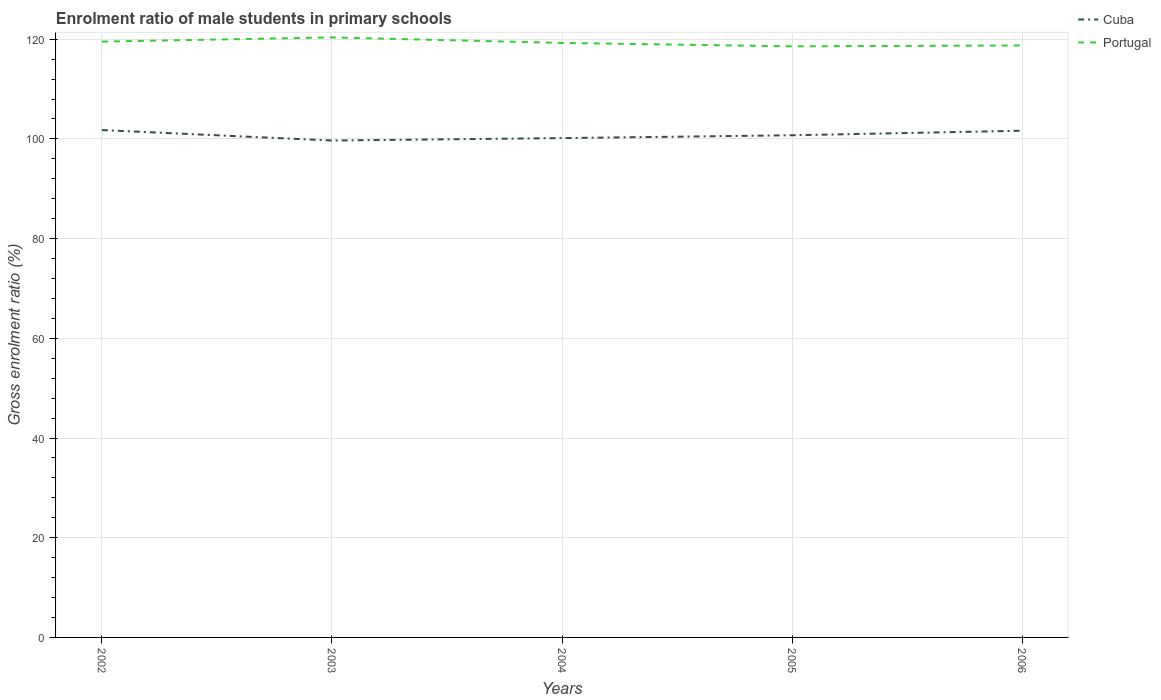Is the number of lines equal to the number of legend labels?
Make the answer very short. Yes. Across all years, what is the maximum enrolment ratio of male students in primary schools in Cuba?
Offer a very short reply. 99.68. What is the total enrolment ratio of male students in primary schools in Cuba in the graph?
Give a very brief answer. -0.57. What is the difference between the highest and the second highest enrolment ratio of male students in primary schools in Cuba?
Offer a terse response. 2.1. Is the enrolment ratio of male students in primary schools in Cuba strictly greater than the enrolment ratio of male students in primary schools in Portugal over the years?
Your answer should be very brief. Yes. How many years are there in the graph?
Provide a short and direct response. 5. What is the difference between two consecutive major ticks on the Y-axis?
Provide a short and direct response. 20. Are the values on the major ticks of Y-axis written in scientific E-notation?
Keep it short and to the point. No. Where does the legend appear in the graph?
Offer a terse response. Top right. How many legend labels are there?
Make the answer very short. 2. What is the title of the graph?
Provide a succinct answer. Enrolment ratio of male students in primary schools. What is the label or title of the X-axis?
Ensure brevity in your answer.  Years. What is the label or title of the Y-axis?
Offer a very short reply. Gross enrolment ratio (%). What is the Gross enrolment ratio (%) in Cuba in 2002?
Your response must be concise. 101.78. What is the Gross enrolment ratio (%) of Portugal in 2002?
Provide a short and direct response. 119.52. What is the Gross enrolment ratio (%) of Cuba in 2003?
Your response must be concise. 99.68. What is the Gross enrolment ratio (%) in Portugal in 2003?
Keep it short and to the point. 120.37. What is the Gross enrolment ratio (%) of Cuba in 2004?
Provide a succinct answer. 100.17. What is the Gross enrolment ratio (%) of Portugal in 2004?
Ensure brevity in your answer.  119.26. What is the Gross enrolment ratio (%) in Cuba in 2005?
Ensure brevity in your answer.  100.73. What is the Gross enrolment ratio (%) of Portugal in 2005?
Your answer should be compact. 118.57. What is the Gross enrolment ratio (%) of Cuba in 2006?
Your answer should be very brief. 101.65. What is the Gross enrolment ratio (%) in Portugal in 2006?
Make the answer very short. 118.76. Across all years, what is the maximum Gross enrolment ratio (%) in Cuba?
Make the answer very short. 101.78. Across all years, what is the maximum Gross enrolment ratio (%) of Portugal?
Provide a succinct answer. 120.37. Across all years, what is the minimum Gross enrolment ratio (%) of Cuba?
Offer a terse response. 99.68. Across all years, what is the minimum Gross enrolment ratio (%) in Portugal?
Your answer should be compact. 118.57. What is the total Gross enrolment ratio (%) of Cuba in the graph?
Ensure brevity in your answer.  504.01. What is the total Gross enrolment ratio (%) of Portugal in the graph?
Your answer should be very brief. 596.47. What is the difference between the Gross enrolment ratio (%) of Cuba in 2002 and that in 2003?
Your response must be concise. 2.1. What is the difference between the Gross enrolment ratio (%) in Portugal in 2002 and that in 2003?
Your answer should be very brief. -0.85. What is the difference between the Gross enrolment ratio (%) of Cuba in 2002 and that in 2004?
Your answer should be compact. 1.61. What is the difference between the Gross enrolment ratio (%) of Portugal in 2002 and that in 2004?
Offer a very short reply. 0.26. What is the difference between the Gross enrolment ratio (%) of Cuba in 2002 and that in 2005?
Provide a short and direct response. 1.05. What is the difference between the Gross enrolment ratio (%) in Portugal in 2002 and that in 2005?
Provide a short and direct response. 0.94. What is the difference between the Gross enrolment ratio (%) in Cuba in 2002 and that in 2006?
Your answer should be compact. 0.13. What is the difference between the Gross enrolment ratio (%) of Portugal in 2002 and that in 2006?
Provide a succinct answer. 0.76. What is the difference between the Gross enrolment ratio (%) in Cuba in 2003 and that in 2004?
Make the answer very short. -0.49. What is the difference between the Gross enrolment ratio (%) of Portugal in 2003 and that in 2004?
Your answer should be compact. 1.11. What is the difference between the Gross enrolment ratio (%) in Cuba in 2003 and that in 2005?
Your answer should be very brief. -1.05. What is the difference between the Gross enrolment ratio (%) of Portugal in 2003 and that in 2005?
Offer a very short reply. 1.79. What is the difference between the Gross enrolment ratio (%) in Cuba in 2003 and that in 2006?
Provide a short and direct response. -1.97. What is the difference between the Gross enrolment ratio (%) in Portugal in 2003 and that in 2006?
Offer a terse response. 1.61. What is the difference between the Gross enrolment ratio (%) of Cuba in 2004 and that in 2005?
Your response must be concise. -0.57. What is the difference between the Gross enrolment ratio (%) in Portugal in 2004 and that in 2005?
Make the answer very short. 0.68. What is the difference between the Gross enrolment ratio (%) of Cuba in 2004 and that in 2006?
Give a very brief answer. -1.48. What is the difference between the Gross enrolment ratio (%) of Portugal in 2004 and that in 2006?
Offer a terse response. 0.5. What is the difference between the Gross enrolment ratio (%) in Cuba in 2005 and that in 2006?
Provide a succinct answer. -0.91. What is the difference between the Gross enrolment ratio (%) in Portugal in 2005 and that in 2006?
Your response must be concise. -0.18. What is the difference between the Gross enrolment ratio (%) in Cuba in 2002 and the Gross enrolment ratio (%) in Portugal in 2003?
Keep it short and to the point. -18.59. What is the difference between the Gross enrolment ratio (%) in Cuba in 2002 and the Gross enrolment ratio (%) in Portugal in 2004?
Offer a terse response. -17.48. What is the difference between the Gross enrolment ratio (%) in Cuba in 2002 and the Gross enrolment ratio (%) in Portugal in 2005?
Your response must be concise. -16.79. What is the difference between the Gross enrolment ratio (%) in Cuba in 2002 and the Gross enrolment ratio (%) in Portugal in 2006?
Your answer should be very brief. -16.98. What is the difference between the Gross enrolment ratio (%) of Cuba in 2003 and the Gross enrolment ratio (%) of Portugal in 2004?
Offer a very short reply. -19.58. What is the difference between the Gross enrolment ratio (%) in Cuba in 2003 and the Gross enrolment ratio (%) in Portugal in 2005?
Give a very brief answer. -18.9. What is the difference between the Gross enrolment ratio (%) of Cuba in 2003 and the Gross enrolment ratio (%) of Portugal in 2006?
Provide a short and direct response. -19.08. What is the difference between the Gross enrolment ratio (%) in Cuba in 2004 and the Gross enrolment ratio (%) in Portugal in 2005?
Provide a succinct answer. -18.41. What is the difference between the Gross enrolment ratio (%) of Cuba in 2004 and the Gross enrolment ratio (%) of Portugal in 2006?
Your answer should be compact. -18.59. What is the difference between the Gross enrolment ratio (%) of Cuba in 2005 and the Gross enrolment ratio (%) of Portugal in 2006?
Provide a succinct answer. -18.02. What is the average Gross enrolment ratio (%) in Cuba per year?
Your response must be concise. 100.8. What is the average Gross enrolment ratio (%) in Portugal per year?
Your answer should be very brief. 119.29. In the year 2002, what is the difference between the Gross enrolment ratio (%) in Cuba and Gross enrolment ratio (%) in Portugal?
Offer a very short reply. -17.74. In the year 2003, what is the difference between the Gross enrolment ratio (%) in Cuba and Gross enrolment ratio (%) in Portugal?
Make the answer very short. -20.69. In the year 2004, what is the difference between the Gross enrolment ratio (%) in Cuba and Gross enrolment ratio (%) in Portugal?
Offer a very short reply. -19.09. In the year 2005, what is the difference between the Gross enrolment ratio (%) of Cuba and Gross enrolment ratio (%) of Portugal?
Your response must be concise. -17.84. In the year 2006, what is the difference between the Gross enrolment ratio (%) of Cuba and Gross enrolment ratio (%) of Portugal?
Your answer should be compact. -17.11. What is the ratio of the Gross enrolment ratio (%) of Cuba in 2002 to that in 2003?
Offer a terse response. 1.02. What is the ratio of the Gross enrolment ratio (%) in Cuba in 2002 to that in 2004?
Keep it short and to the point. 1.02. What is the ratio of the Gross enrolment ratio (%) in Portugal in 2002 to that in 2004?
Make the answer very short. 1. What is the ratio of the Gross enrolment ratio (%) in Cuba in 2002 to that in 2005?
Keep it short and to the point. 1.01. What is the ratio of the Gross enrolment ratio (%) of Cuba in 2002 to that in 2006?
Keep it short and to the point. 1. What is the ratio of the Gross enrolment ratio (%) in Portugal in 2002 to that in 2006?
Provide a short and direct response. 1.01. What is the ratio of the Gross enrolment ratio (%) in Portugal in 2003 to that in 2004?
Ensure brevity in your answer.  1.01. What is the ratio of the Gross enrolment ratio (%) of Cuba in 2003 to that in 2005?
Offer a terse response. 0.99. What is the ratio of the Gross enrolment ratio (%) in Portugal in 2003 to that in 2005?
Provide a short and direct response. 1.02. What is the ratio of the Gross enrolment ratio (%) in Cuba in 2003 to that in 2006?
Make the answer very short. 0.98. What is the ratio of the Gross enrolment ratio (%) in Portugal in 2003 to that in 2006?
Provide a succinct answer. 1.01. What is the ratio of the Gross enrolment ratio (%) in Cuba in 2004 to that in 2005?
Give a very brief answer. 0.99. What is the ratio of the Gross enrolment ratio (%) in Cuba in 2004 to that in 2006?
Offer a very short reply. 0.99. What is the difference between the highest and the second highest Gross enrolment ratio (%) of Cuba?
Keep it short and to the point. 0.13. What is the difference between the highest and the second highest Gross enrolment ratio (%) of Portugal?
Keep it short and to the point. 0.85. What is the difference between the highest and the lowest Gross enrolment ratio (%) of Cuba?
Offer a very short reply. 2.1. What is the difference between the highest and the lowest Gross enrolment ratio (%) of Portugal?
Provide a succinct answer. 1.79. 